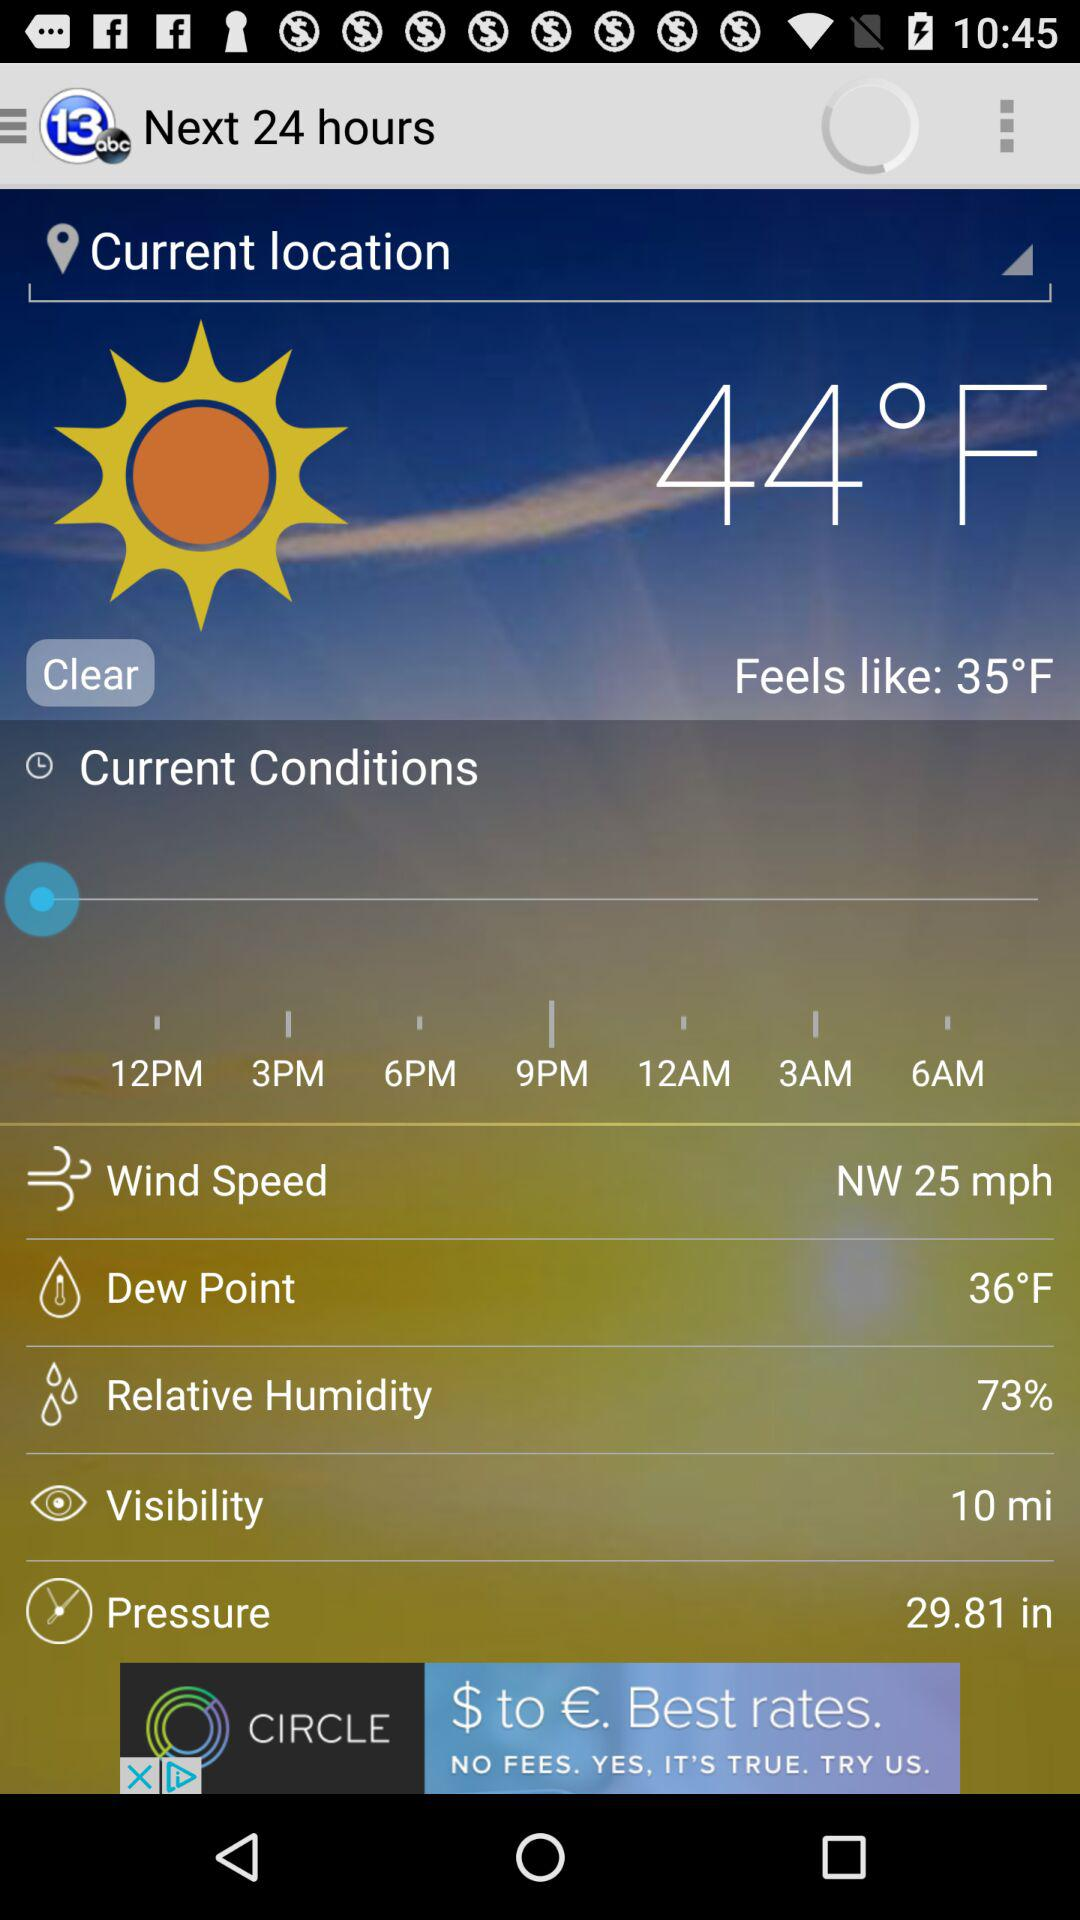What is the pressure? The pressure is 29.81 in. 